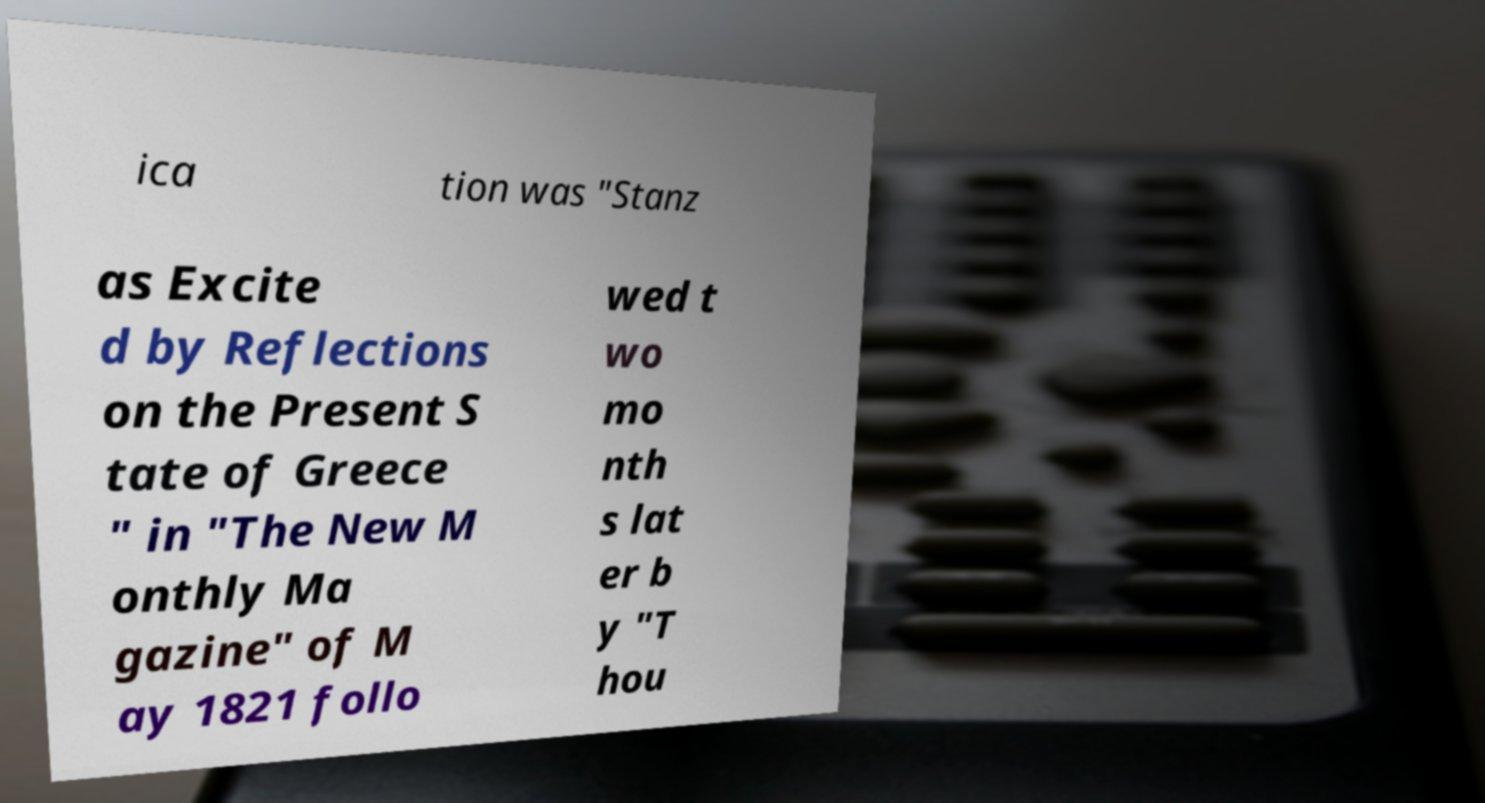Can you accurately transcribe the text from the provided image for me? ica tion was "Stanz as Excite d by Reflections on the Present S tate of Greece " in "The New M onthly Ma gazine" of M ay 1821 follo wed t wo mo nth s lat er b y "T hou 